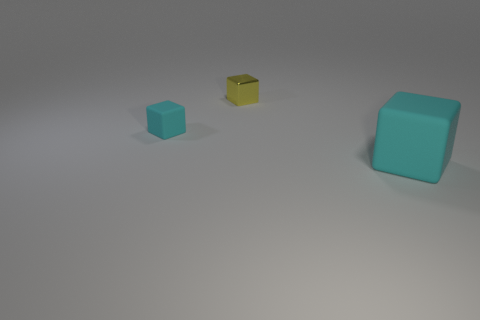There is a tiny rubber object that is the same shape as the yellow metal thing; what is its color?
Your response must be concise. Cyan. How many tiny things are the same color as the big rubber object?
Give a very brief answer. 1. There is a yellow block behind the large cyan matte thing; is its size the same as the matte cube that is behind the big rubber cube?
Provide a succinct answer. Yes. Does the shiny object have the same size as the cyan rubber cube to the left of the small metallic cube?
Provide a succinct answer. Yes. The yellow cube is what size?
Your response must be concise. Small. What color is the big thing that is made of the same material as the tiny cyan thing?
Your answer should be compact. Cyan. What number of tiny cyan things are made of the same material as the small yellow cube?
Your answer should be very brief. 0. How many things are large cyan matte things or cubes to the left of the small yellow thing?
Provide a succinct answer. 2. Is the material of the small block that is on the right side of the tiny cyan matte block the same as the big cyan block?
Keep it short and to the point. No. What color is the rubber thing that is the same size as the yellow metal cube?
Offer a terse response. Cyan. 